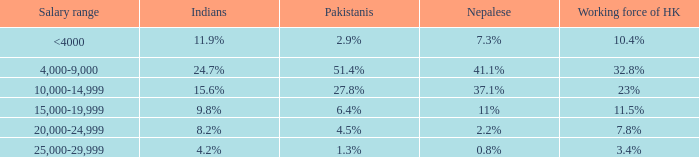What is the salary range for the 10.4% workforce in hong kong? <4000. 